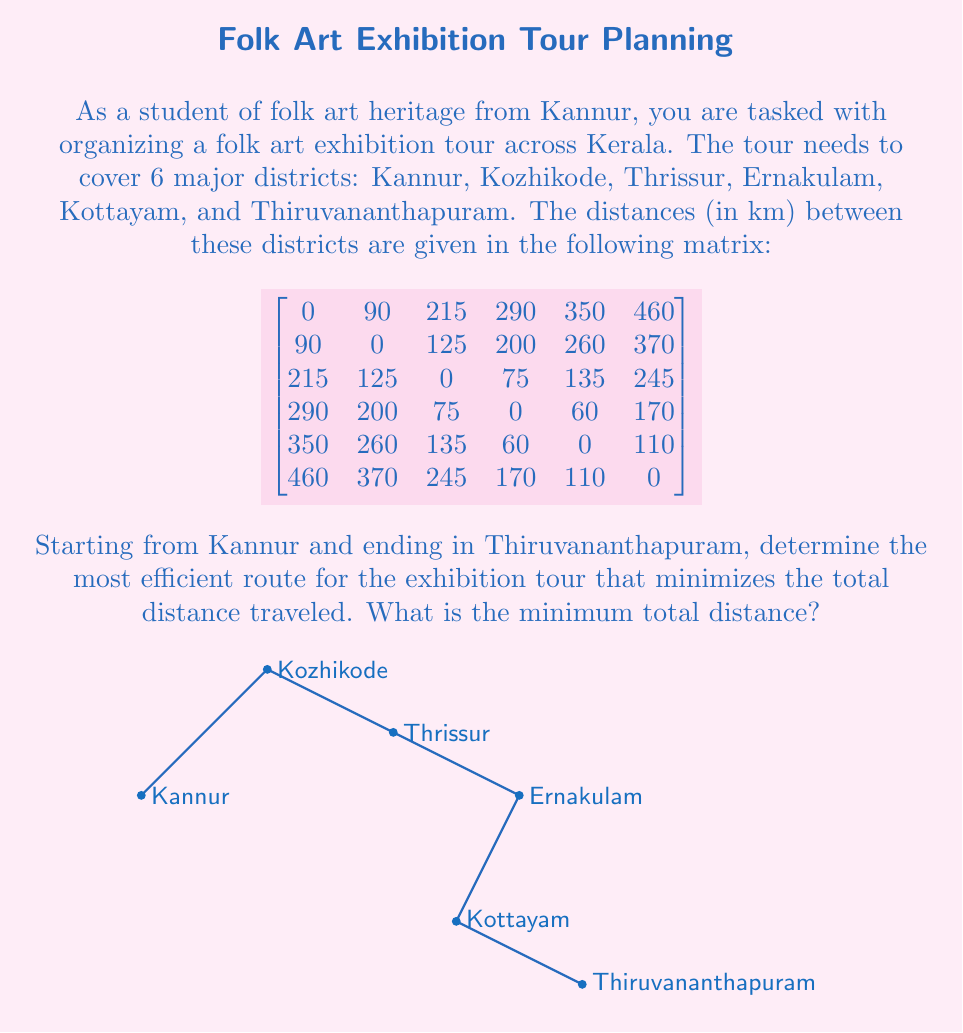Give your solution to this math problem. To solve this problem, we can use the Nearest Neighbor algorithm, which is a heuristic method for solving the Traveling Salesman Problem. While it doesn't guarantee the optimal solution, it often provides a good approximation.

Step 1: Start from Kannur.

Step 2: Find the nearest unvisited city:
- Kozhikode (90 km)

Step 3: Move to Kozhikode and find the nearest unvisited city:
- Thrissur (125 km)

Step 4: Move to Thrissur and find the nearest unvisited city:
- Ernakulam (75 km)

Step 5: Move to Ernakulam and find the nearest unvisited city:
- Kottayam (60 km)

Step 6: Move to Kottayam. The only remaining city is Thiruvananthapuram (110 km).

Step 7: Calculate the total distance:
$$90 + 125 + 75 + 60 + 110 = 460 \text{ km}$$

Therefore, the most efficient route is:
Kannur → Kozhikode → Thrissur → Ernakulam → Kottayam → Thiruvananthapuram

Note: This solution assumes that the Nearest Neighbor algorithm provides the optimal route in this case. In practice, more sophisticated algorithms like the Held-Karp algorithm or branch and bound methods might be used for larger problems to guarantee optimality.
Answer: 460 km 